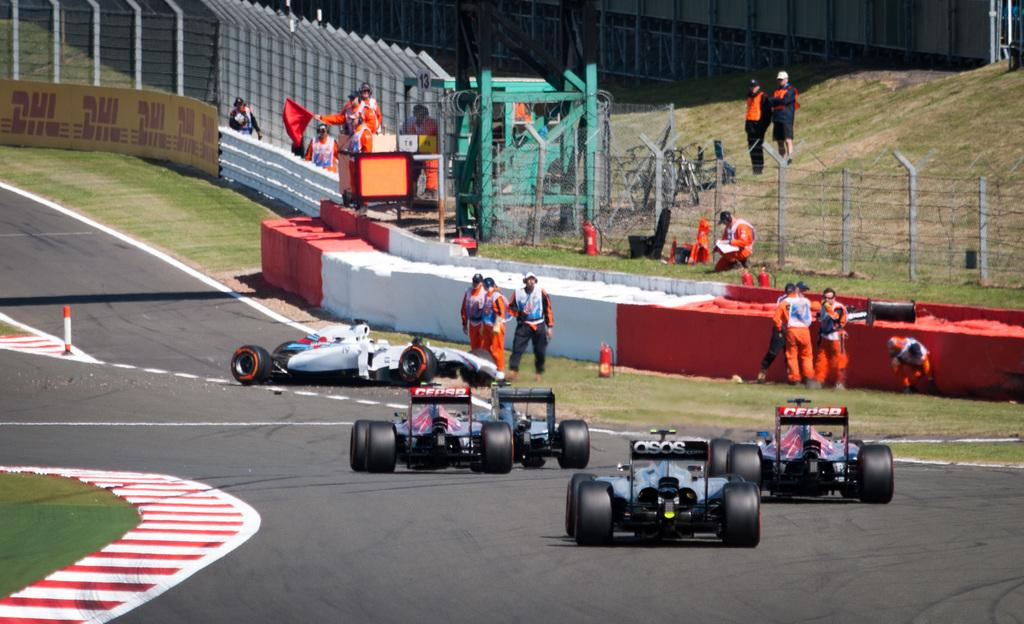What can be seen on the road in the image? There are vehicles on the road in the image. Can you identify any living beings in the image? Yes, there are people visible in the image. What type of barrier is present in the image? There is a fence in the image. What type of vegetation is present in the image? There is grass in the image. What type of signage or advertisement can be seen in the image? There is a hoarding (hoarding) in the image. What type of destruction can be seen in the image? There is no destruction present in the image. What type of dust can be seen in the image? There is no dust present in the image. 